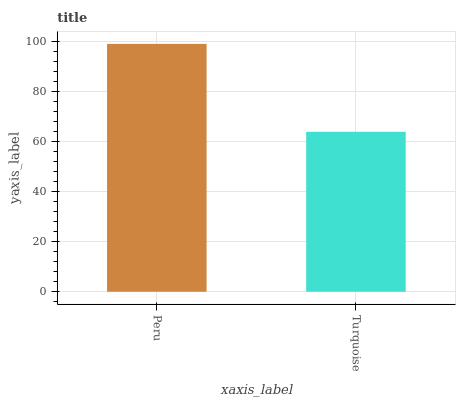Is Turquoise the maximum?
Answer yes or no. No. Is Peru greater than Turquoise?
Answer yes or no. Yes. Is Turquoise less than Peru?
Answer yes or no. Yes. Is Turquoise greater than Peru?
Answer yes or no. No. Is Peru less than Turquoise?
Answer yes or no. No. Is Peru the high median?
Answer yes or no. Yes. Is Turquoise the low median?
Answer yes or no. Yes. Is Turquoise the high median?
Answer yes or no. No. Is Peru the low median?
Answer yes or no. No. 